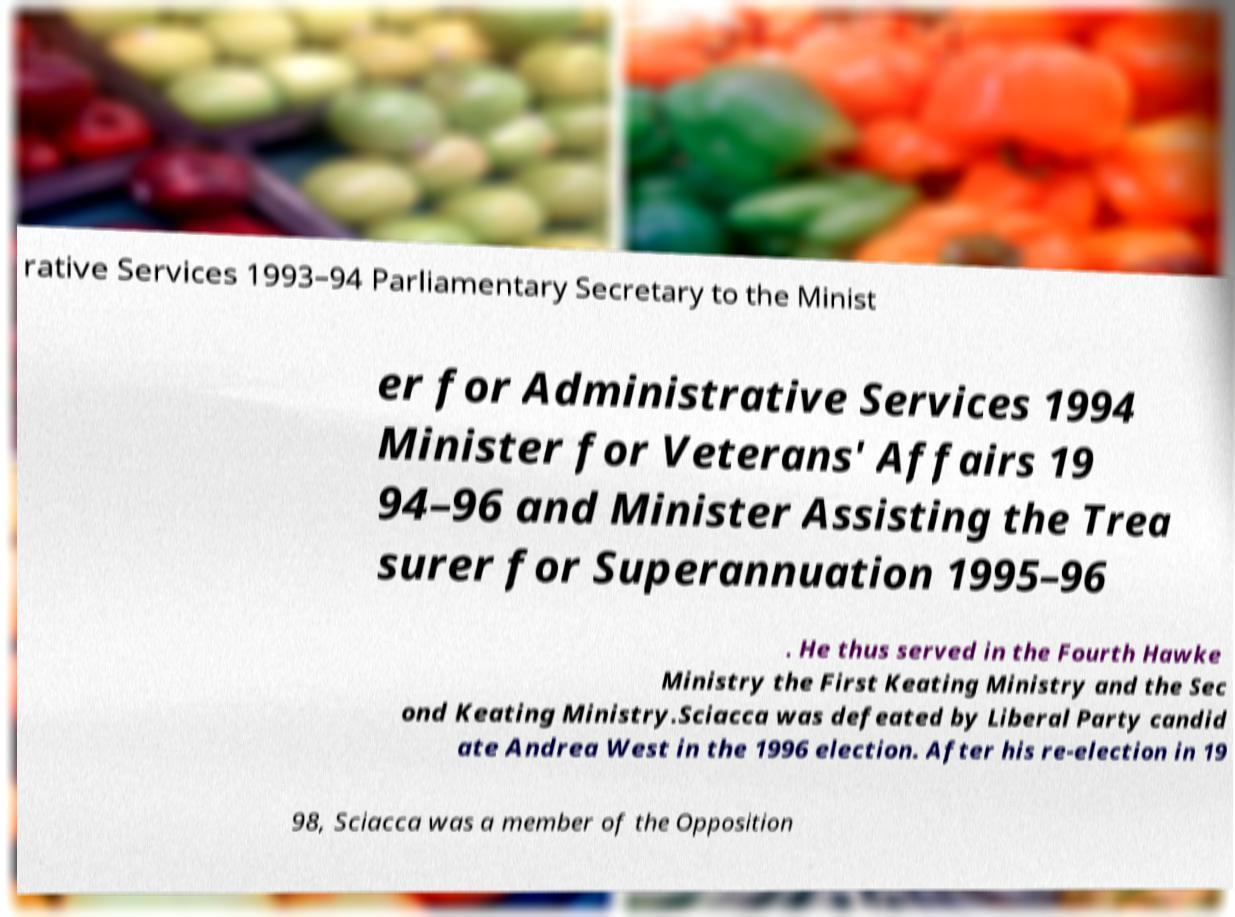For documentation purposes, I need the text within this image transcribed. Could you provide that? rative Services 1993–94 Parliamentary Secretary to the Minist er for Administrative Services 1994 Minister for Veterans' Affairs 19 94–96 and Minister Assisting the Trea surer for Superannuation 1995–96 . He thus served in the Fourth Hawke Ministry the First Keating Ministry and the Sec ond Keating Ministry.Sciacca was defeated by Liberal Party candid ate Andrea West in the 1996 election. After his re-election in 19 98, Sciacca was a member of the Opposition 